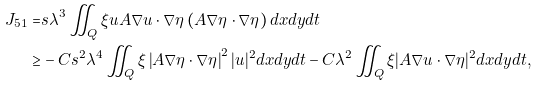<formula> <loc_0><loc_0><loc_500><loc_500>J _ { 5 1 } = & s \lambda ^ { 3 } \iint _ { Q } \xi u A \nabla u \cdot \nabla \eta \left ( A \nabla \eta \cdot \nabla \eta \right ) d x d y d t \\ \geq & - C s ^ { 2 } \lambda ^ { 4 } \iint _ { Q } \xi \left | A \nabla \eta \cdot \nabla \eta \right | ^ { 2 } | u | ^ { 2 } d x d y d t - C \lambda ^ { 2 } \iint _ { Q } \xi | A \nabla u \cdot \nabla \eta | ^ { 2 } d x d y d t ,</formula> 